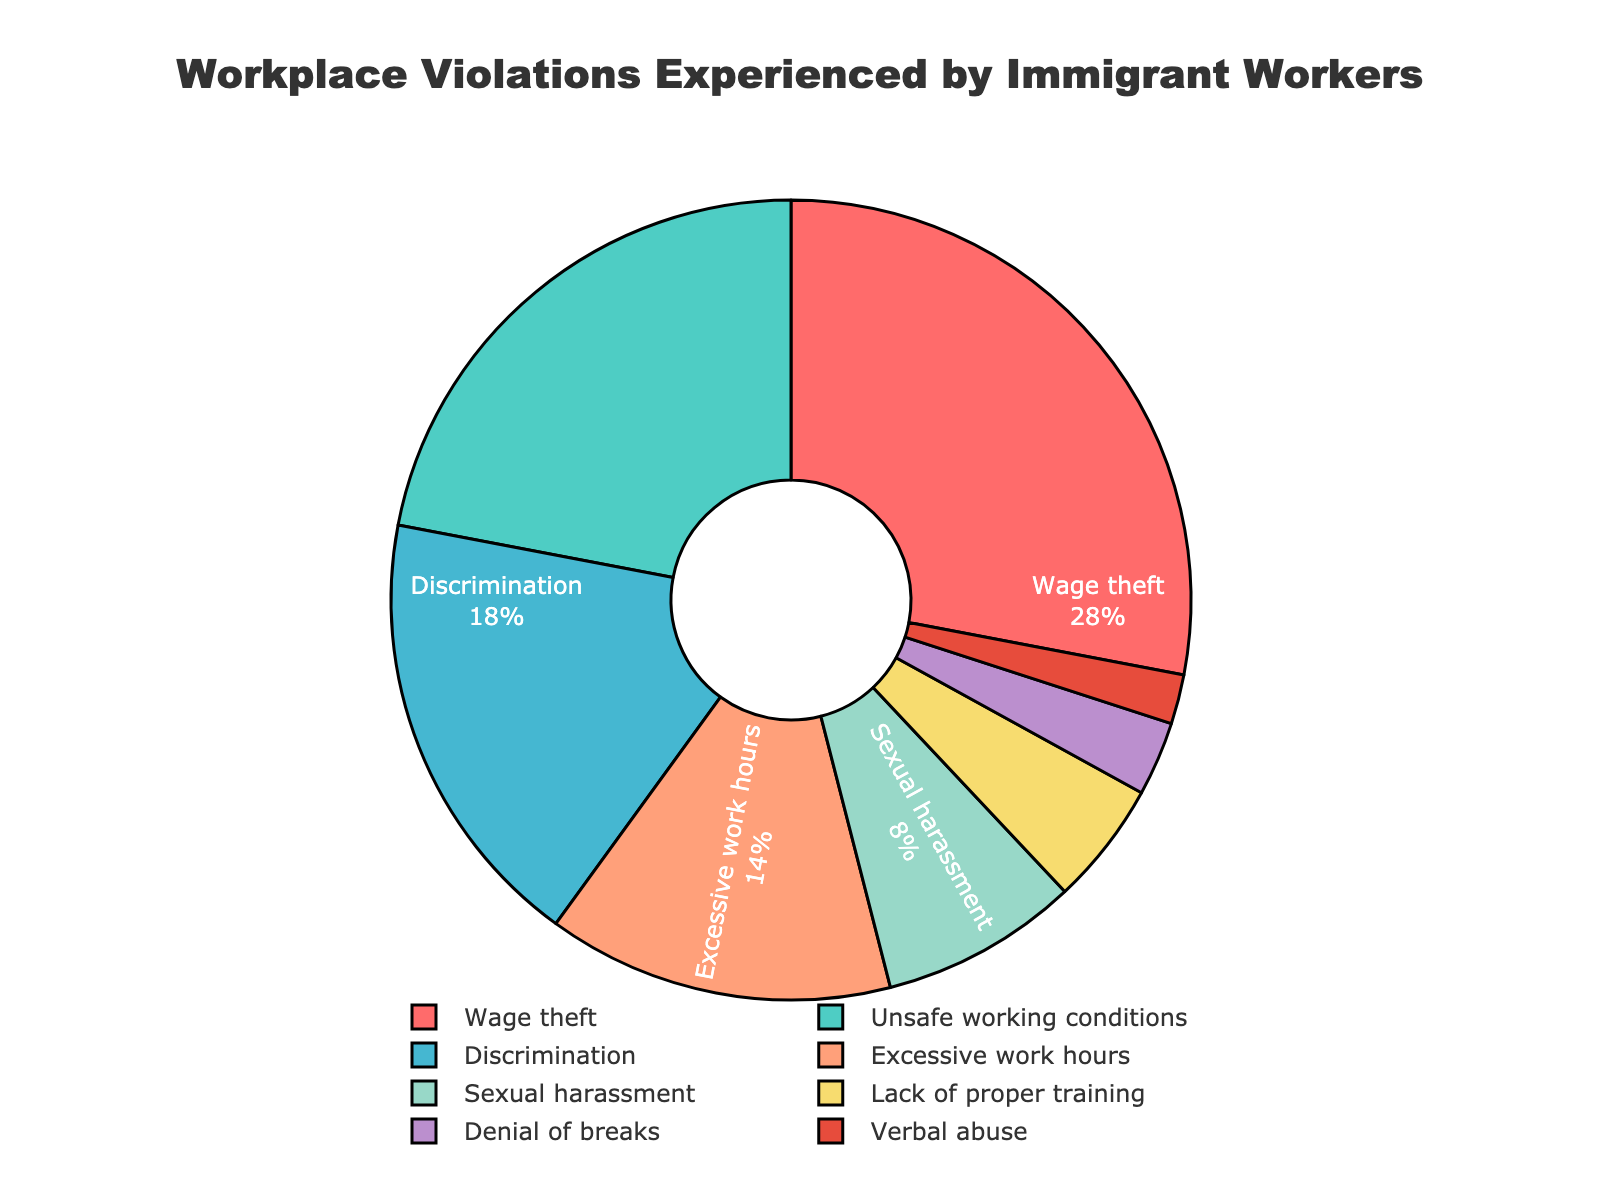What is the most reported workplace violation experienced by immigrant workers? The figure shows a breakdown of workplace violations with their corresponding percentages. By identifying the category with the largest segment, we see that 'Wage theft' has the highest percentage.
Answer: Wage theft Which violation category has double the percentage of 'Denial of breaks'? According to the figure, 'Denial of breaks' is 3%. Doubling this percentage (3% * 2) results in 6%. The closest category above 6% is 'Sexual harassment' at 8%.
Answer: Sexual harassment What is the combined percentage of 'Unsafe working conditions' and 'Lack of proper training'? From the figure, 'Unsafe working conditions' is 22% and 'Lack of proper training' is 5%. Adding these percentages together (22% + 5%) gives a combined percentage of 27%.
Answer: 27% How much more common is 'Discrimination' compared to 'Verbal abuse'? 'Discrimination' is 18%, and 'Verbal abuse' is 2%. The difference between these values (18% - 2%) is 16%.
Answer: 16% Which categories have a percentage below 10%? By inspecting the figure, the categories with percentages below 10% are 'Sexual harassment' (8%), 'Lack of proper training' (5%), 'Denial of breaks' (3%), and 'Verbal abuse' (2%).
Answer: Sexual harassment, Lack of proper training, Denial of breaks, Verbal abuse What is the total percentage represented by 'Wage theft', 'Discrimination', and 'Excessive work hours'? The figure shows 'Wage theft' at 28%, 'Discrimination' at 18%, and 'Excessive work hours' at 14%. Summing these percentages (28% + 18% + 14%) results in a total of 60%.
Answer: 60% How does 'Unsafe working conditions' compare to 'Excessive work hours' in terms of percentage? 'Unsafe working conditions' is shown as 22%, whereas 'Excessive work hours' is 14%. Comparing these values, 22% is greater than 14%.
Answer: Unsafe working conditions are greater What is the difference in percentages between 'Sexual harassment' and 'Lack of proper training'? 'Sexual harassment' is 8%, and 'Lack of proper training' is 5%. Subtracting these values (8% - 5%) gives a difference of 3%.
Answer: 3% Which colored segment represents 'Wage theft'? Observing the colors associated with each category in the figure, 'Wage theft' is represented by the red segment.
Answer: Red 